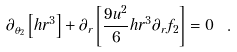Convert formula to latex. <formula><loc_0><loc_0><loc_500><loc_500>\partial _ { \theta _ { 2 } } \left [ h r ^ { 3 } \right ] + \partial _ { r } \left [ \frac { 9 u ^ { 2 } } { 6 } h r ^ { 3 } \partial _ { r } f _ { 2 } \right ] = 0 \ .</formula> 